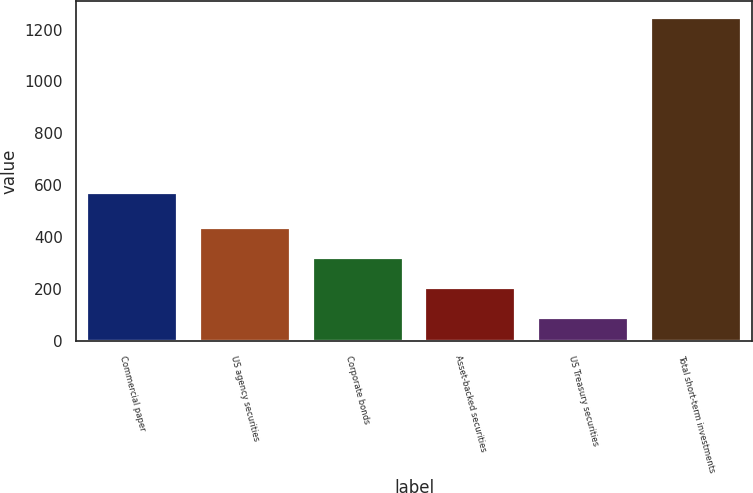Convert chart. <chart><loc_0><loc_0><loc_500><loc_500><bar_chart><fcel>Commercial paper<fcel>US agency securities<fcel>Corporate bonds<fcel>Asset-backed securities<fcel>US Treasury securities<fcel>Total short-term investments<nl><fcel>572<fcel>436.8<fcel>321.2<fcel>205.6<fcel>90<fcel>1246<nl></chart> 